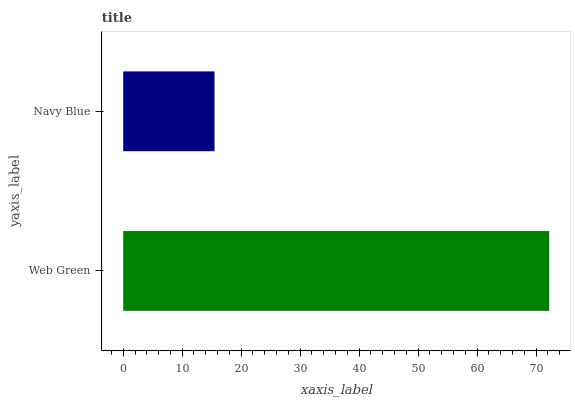Is Navy Blue the minimum?
Answer yes or no. Yes. Is Web Green the maximum?
Answer yes or no. Yes. Is Navy Blue the maximum?
Answer yes or no. No. Is Web Green greater than Navy Blue?
Answer yes or no. Yes. Is Navy Blue less than Web Green?
Answer yes or no. Yes. Is Navy Blue greater than Web Green?
Answer yes or no. No. Is Web Green less than Navy Blue?
Answer yes or no. No. Is Web Green the high median?
Answer yes or no. Yes. Is Navy Blue the low median?
Answer yes or no. Yes. Is Navy Blue the high median?
Answer yes or no. No. Is Web Green the low median?
Answer yes or no. No. 